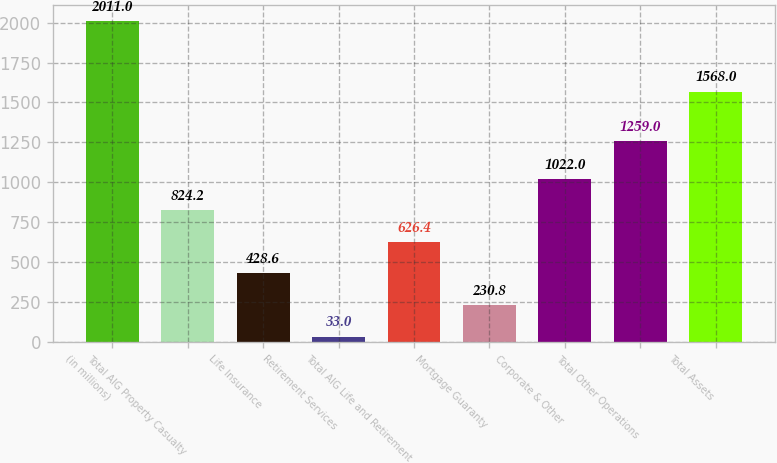Convert chart. <chart><loc_0><loc_0><loc_500><loc_500><bar_chart><fcel>(in millions)<fcel>Total AIG Property Casualty<fcel>Life Insurance<fcel>Retirement Services<fcel>Total AIG Life and Retirement<fcel>Mortgage Guaranty<fcel>Corporate & Other<fcel>Total Other Operations<fcel>Total Assets<nl><fcel>2011<fcel>824.2<fcel>428.6<fcel>33<fcel>626.4<fcel>230.8<fcel>1022<fcel>1259<fcel>1568<nl></chart> 